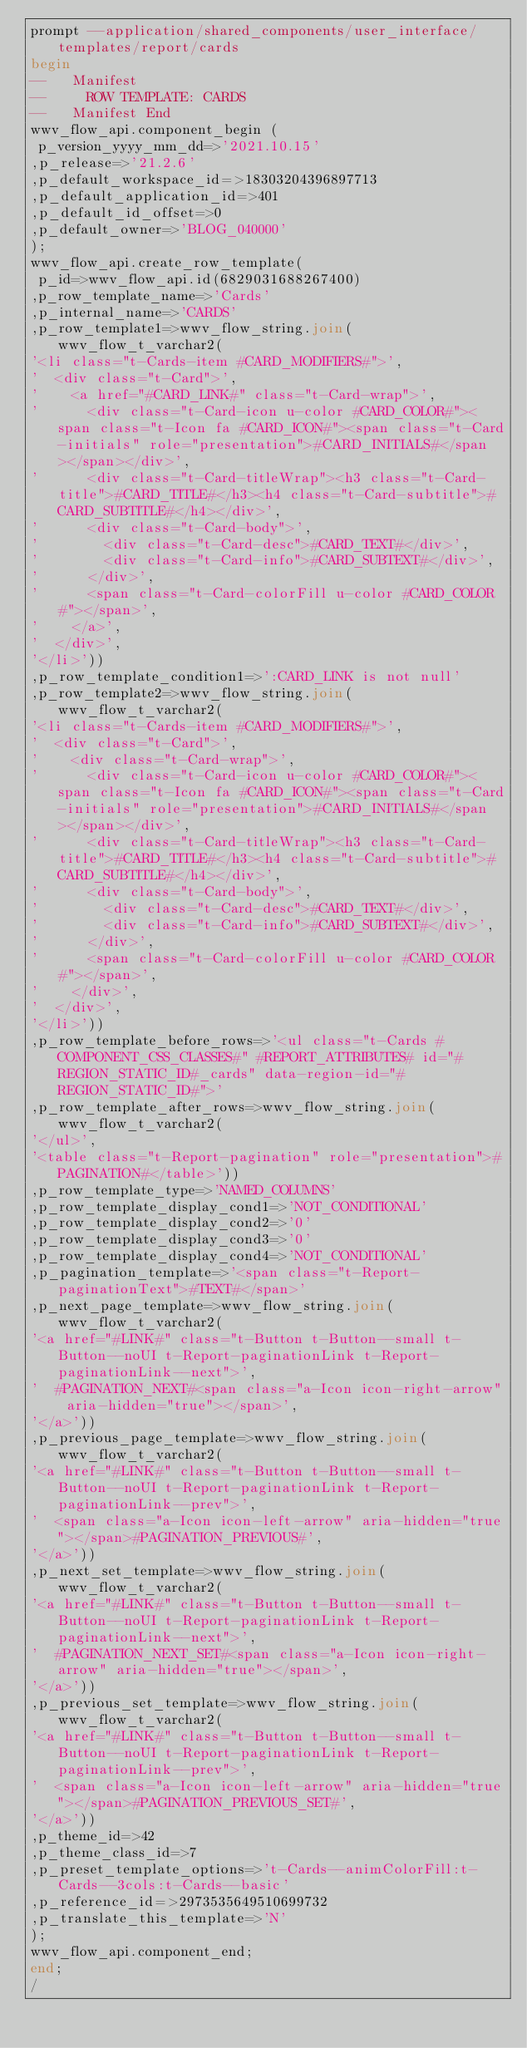Convert code to text. <code><loc_0><loc_0><loc_500><loc_500><_SQL_>prompt --application/shared_components/user_interface/templates/report/cards
begin
--   Manifest
--     ROW TEMPLATE: CARDS
--   Manifest End
wwv_flow_api.component_begin (
 p_version_yyyy_mm_dd=>'2021.10.15'
,p_release=>'21.2.6'
,p_default_workspace_id=>18303204396897713
,p_default_application_id=>401
,p_default_id_offset=>0
,p_default_owner=>'BLOG_040000'
);
wwv_flow_api.create_row_template(
 p_id=>wwv_flow_api.id(6829031688267400)
,p_row_template_name=>'Cards'
,p_internal_name=>'CARDS'
,p_row_template1=>wwv_flow_string.join(wwv_flow_t_varchar2(
'<li class="t-Cards-item #CARD_MODIFIERS#">',
'  <div class="t-Card">',
'    <a href="#CARD_LINK#" class="t-Card-wrap">',
'      <div class="t-Card-icon u-color #CARD_COLOR#"><span class="t-Icon fa #CARD_ICON#"><span class="t-Card-initials" role="presentation">#CARD_INITIALS#</span></span></div>',
'      <div class="t-Card-titleWrap"><h3 class="t-Card-title">#CARD_TITLE#</h3><h4 class="t-Card-subtitle">#CARD_SUBTITLE#</h4></div>',
'      <div class="t-Card-body">',
'        <div class="t-Card-desc">#CARD_TEXT#</div>',
'        <div class="t-Card-info">#CARD_SUBTEXT#</div>',
'      </div>',
'      <span class="t-Card-colorFill u-color #CARD_COLOR#"></span>',
'    </a>',
'  </div>',
'</li>'))
,p_row_template_condition1=>':CARD_LINK is not null'
,p_row_template2=>wwv_flow_string.join(wwv_flow_t_varchar2(
'<li class="t-Cards-item #CARD_MODIFIERS#">',
'  <div class="t-Card">',
'    <div class="t-Card-wrap">',
'      <div class="t-Card-icon u-color #CARD_COLOR#"><span class="t-Icon fa #CARD_ICON#"><span class="t-Card-initials" role="presentation">#CARD_INITIALS#</span></span></div>',
'      <div class="t-Card-titleWrap"><h3 class="t-Card-title">#CARD_TITLE#</h3><h4 class="t-Card-subtitle">#CARD_SUBTITLE#</h4></div>',
'      <div class="t-Card-body">',
'        <div class="t-Card-desc">#CARD_TEXT#</div>',
'        <div class="t-Card-info">#CARD_SUBTEXT#</div>',
'      </div>',
'      <span class="t-Card-colorFill u-color #CARD_COLOR#"></span>',
'    </div>',
'  </div>',
'</li>'))
,p_row_template_before_rows=>'<ul class="t-Cards #COMPONENT_CSS_CLASSES#" #REPORT_ATTRIBUTES# id="#REGION_STATIC_ID#_cards" data-region-id="#REGION_STATIC_ID#">'
,p_row_template_after_rows=>wwv_flow_string.join(wwv_flow_t_varchar2(
'</ul>',
'<table class="t-Report-pagination" role="presentation">#PAGINATION#</table>'))
,p_row_template_type=>'NAMED_COLUMNS'
,p_row_template_display_cond1=>'NOT_CONDITIONAL'
,p_row_template_display_cond2=>'0'
,p_row_template_display_cond3=>'0'
,p_row_template_display_cond4=>'NOT_CONDITIONAL'
,p_pagination_template=>'<span class="t-Report-paginationText">#TEXT#</span>'
,p_next_page_template=>wwv_flow_string.join(wwv_flow_t_varchar2(
'<a href="#LINK#" class="t-Button t-Button--small t-Button--noUI t-Report-paginationLink t-Report-paginationLink--next">',
'  #PAGINATION_NEXT#<span class="a-Icon icon-right-arrow" aria-hidden="true"></span>',
'</a>'))
,p_previous_page_template=>wwv_flow_string.join(wwv_flow_t_varchar2(
'<a href="#LINK#" class="t-Button t-Button--small t-Button--noUI t-Report-paginationLink t-Report-paginationLink--prev">',
'  <span class="a-Icon icon-left-arrow" aria-hidden="true"></span>#PAGINATION_PREVIOUS#',
'</a>'))
,p_next_set_template=>wwv_flow_string.join(wwv_flow_t_varchar2(
'<a href="#LINK#" class="t-Button t-Button--small t-Button--noUI t-Report-paginationLink t-Report-paginationLink--next">',
'  #PAGINATION_NEXT_SET#<span class="a-Icon icon-right-arrow" aria-hidden="true"></span>',
'</a>'))
,p_previous_set_template=>wwv_flow_string.join(wwv_flow_t_varchar2(
'<a href="#LINK#" class="t-Button t-Button--small t-Button--noUI t-Report-paginationLink t-Report-paginationLink--prev">',
'  <span class="a-Icon icon-left-arrow" aria-hidden="true"></span>#PAGINATION_PREVIOUS_SET#',
'</a>'))
,p_theme_id=>42
,p_theme_class_id=>7
,p_preset_template_options=>'t-Cards--animColorFill:t-Cards--3cols:t-Cards--basic'
,p_reference_id=>2973535649510699732
,p_translate_this_template=>'N'
);
wwv_flow_api.component_end;
end;
/
</code> 